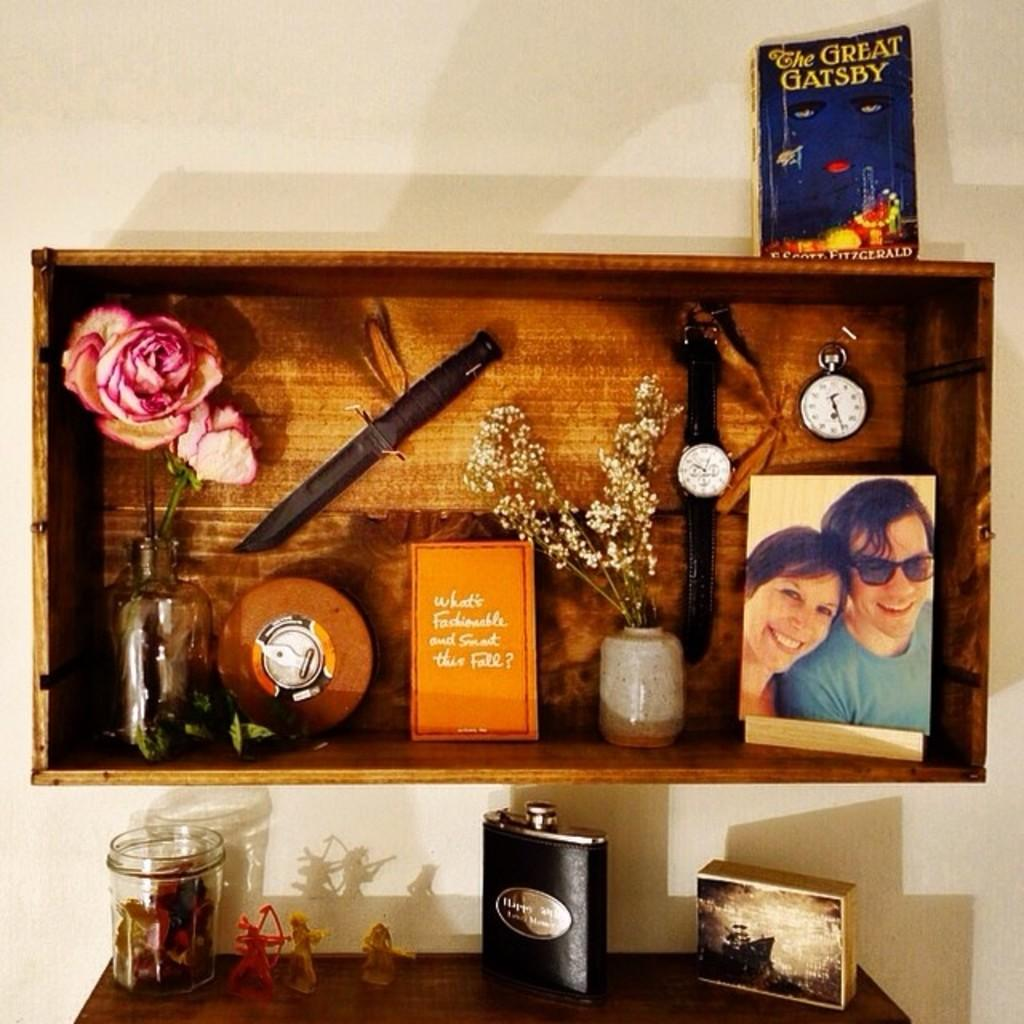<image>
Present a compact description of the photo's key features. A shelf with the Great Gatsby well looking read book on top. 